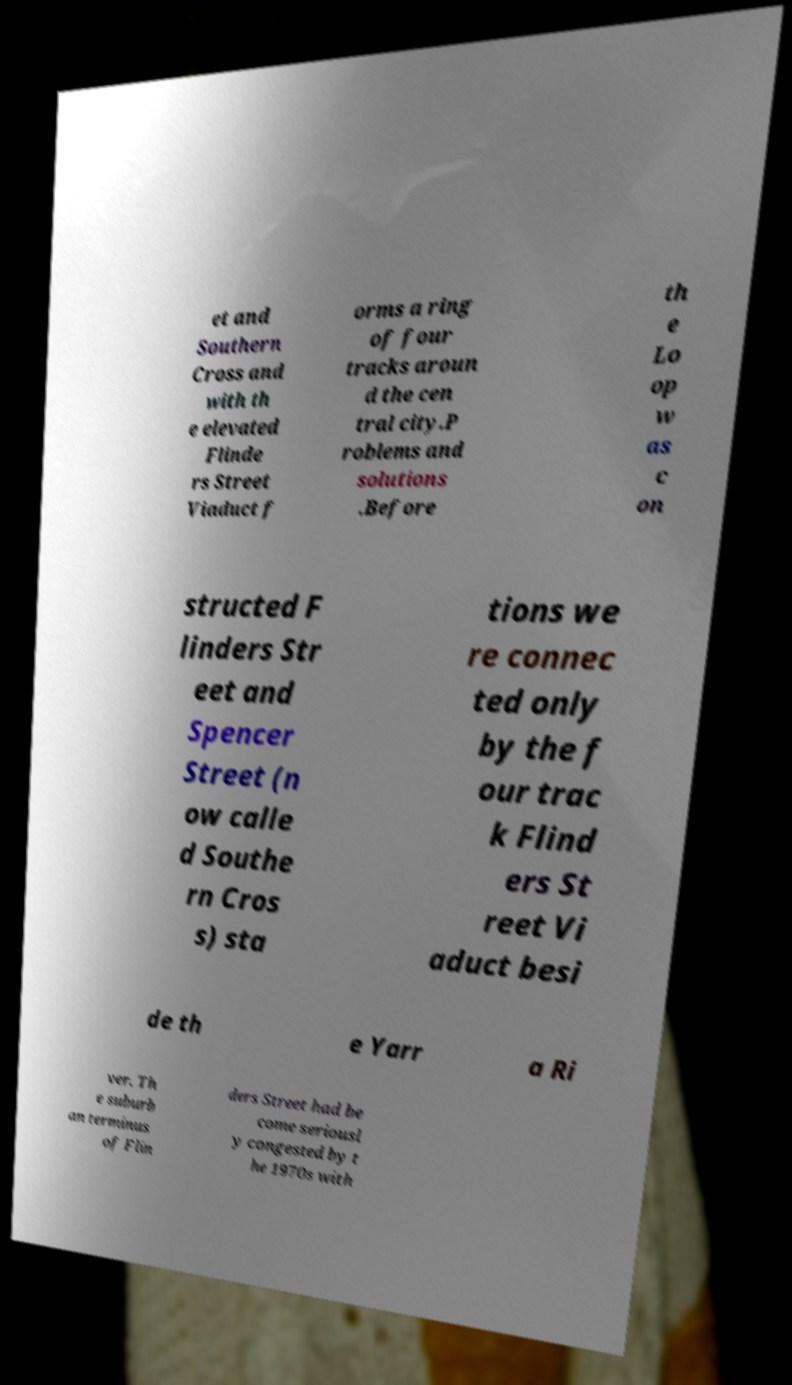Can you accurately transcribe the text from the provided image for me? et and Southern Cross and with th e elevated Flinde rs Street Viaduct f orms a ring of four tracks aroun d the cen tral city.P roblems and solutions .Before th e Lo op w as c on structed F linders Str eet and Spencer Street (n ow calle d Southe rn Cros s) sta tions we re connec ted only by the f our trac k Flind ers St reet Vi aduct besi de th e Yarr a Ri ver. Th e suburb an terminus of Flin ders Street had be come seriousl y congested by t he 1970s with 